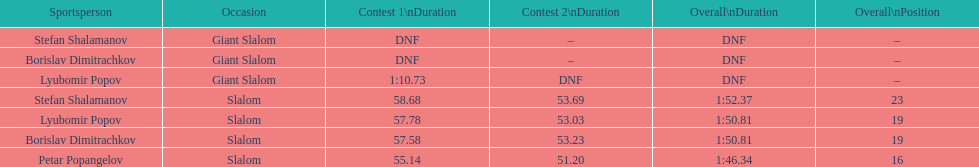Which athlete had a race time above 1:00? Lyubomir Popov. 